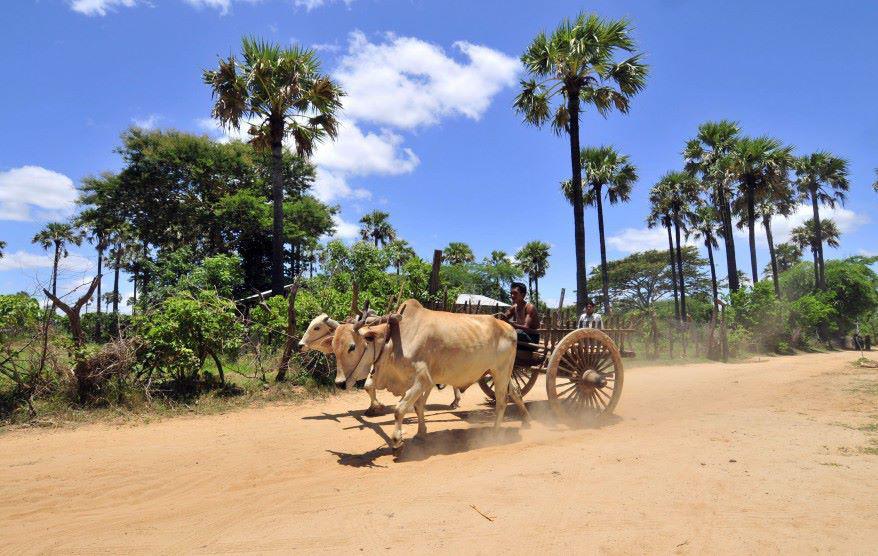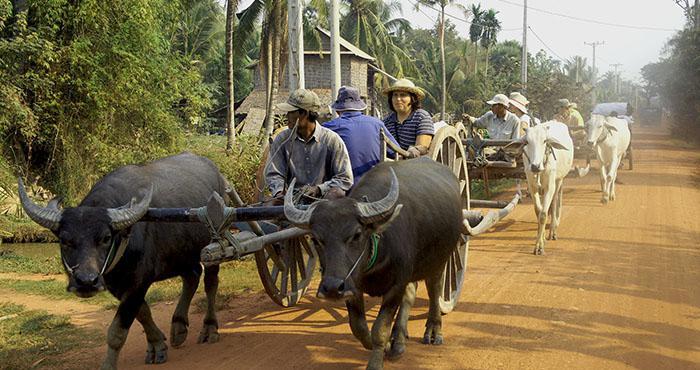The first image is the image on the left, the second image is the image on the right. Evaluate the accuracy of this statement regarding the images: "In one image, two dark oxen pull a two-wheeled cart with two passengers and a driver in a cap leftward.". Is it true? Answer yes or no. Yes. 